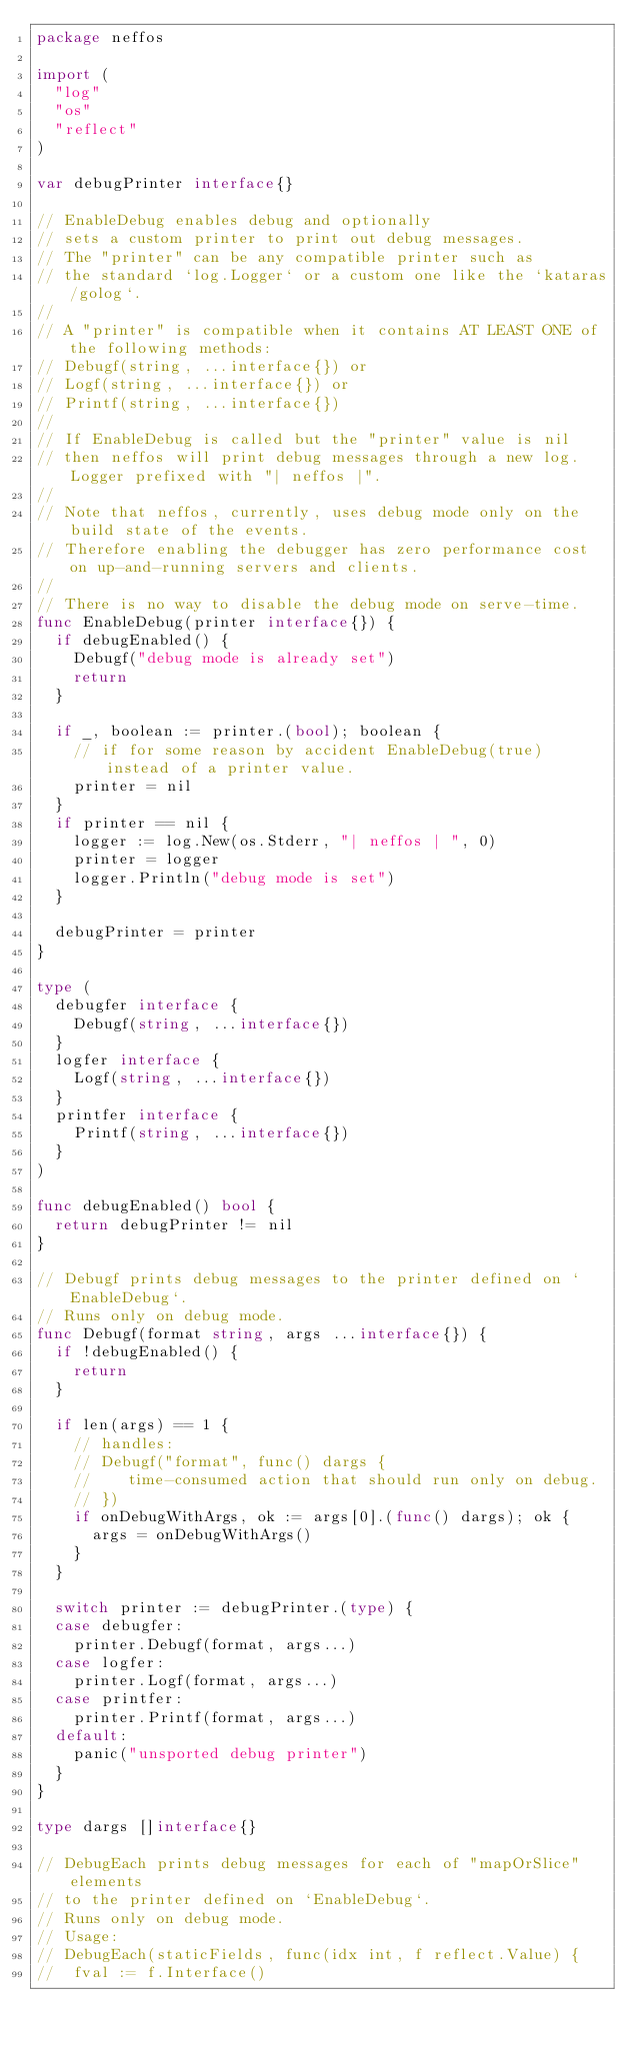Convert code to text. <code><loc_0><loc_0><loc_500><loc_500><_Go_>package neffos

import (
	"log"
	"os"
	"reflect"
)

var debugPrinter interface{}

// EnableDebug enables debug and optionally
// sets a custom printer to print out debug messages.
// The "printer" can be any compatible printer such as
// the standard `log.Logger` or a custom one like the `kataras/golog`.
//
// A "printer" is compatible when it contains AT LEAST ONE of the following methods:
// Debugf(string, ...interface{}) or
// Logf(string, ...interface{}) or
// Printf(string, ...interface{})
//
// If EnableDebug is called but the "printer" value is nil
// then neffos will print debug messages through a new log.Logger prefixed with "| neffos |".
//
// Note that neffos, currently, uses debug mode only on the build state of the events.
// Therefore enabling the debugger has zero performance cost on up-and-running servers and clients.
//
// There is no way to disable the debug mode on serve-time.
func EnableDebug(printer interface{}) {
	if debugEnabled() {
		Debugf("debug mode is already set")
		return
	}

	if _, boolean := printer.(bool); boolean {
		// if for some reason by accident EnableDebug(true) instead of a printer value.
		printer = nil
	}
	if printer == nil {
		logger := log.New(os.Stderr, "| neffos | ", 0)
		printer = logger
		logger.Println("debug mode is set")
	}

	debugPrinter = printer
}

type (
	debugfer interface {
		Debugf(string, ...interface{})
	}
	logfer interface {
		Logf(string, ...interface{})
	}
	printfer interface {
		Printf(string, ...interface{})
	}
)

func debugEnabled() bool {
	return debugPrinter != nil
}

// Debugf prints debug messages to the printer defined on `EnableDebug`.
// Runs only on debug mode.
func Debugf(format string, args ...interface{}) {
	if !debugEnabled() {
		return
	}

	if len(args) == 1 {
		// handles:
		// Debugf("format", func() dargs {
		//    time-consumed action that should run only on debug.
		// })
		if onDebugWithArgs, ok := args[0].(func() dargs); ok {
			args = onDebugWithArgs()
		}
	}

	switch printer := debugPrinter.(type) {
	case debugfer:
		printer.Debugf(format, args...)
	case logfer:
		printer.Logf(format, args...)
	case printfer:
		printer.Printf(format, args...)
	default:
		panic("unsported debug printer")
	}
}

type dargs []interface{}

// DebugEach prints debug messages for each of "mapOrSlice" elements
// to the printer defined on `EnableDebug`.
// Runs only on debug mode.
// Usage:
// DebugEach(staticFields, func(idx int, f reflect.Value) {
// 	fval := f.Interface()</code> 